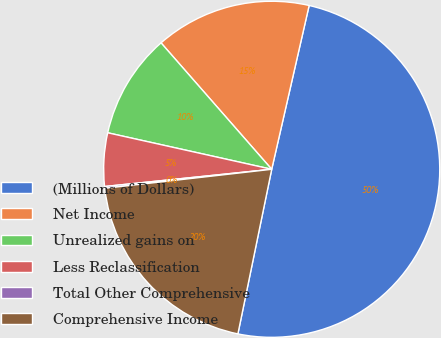Convert chart to OTSL. <chart><loc_0><loc_0><loc_500><loc_500><pie_chart><fcel>(Millions of Dollars)<fcel>Net Income<fcel>Unrealized gains on<fcel>Less Reclassification<fcel>Total Other Comprehensive<fcel>Comprehensive Income<nl><fcel>49.65%<fcel>15.02%<fcel>10.07%<fcel>5.12%<fcel>0.17%<fcel>19.97%<nl></chart> 